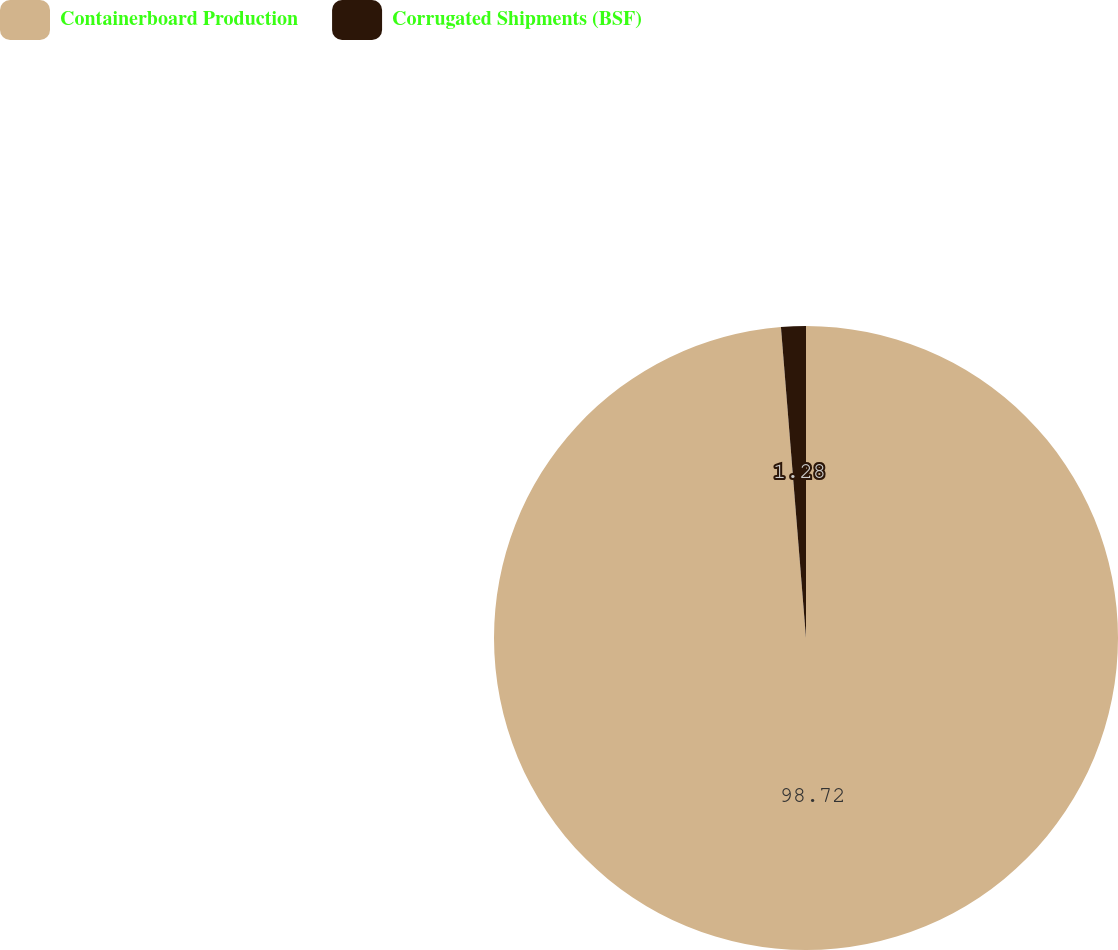<chart> <loc_0><loc_0><loc_500><loc_500><pie_chart><fcel>Containerboard Production<fcel>Corrugated Shipments (BSF)<nl><fcel>98.72%<fcel>1.28%<nl></chart> 